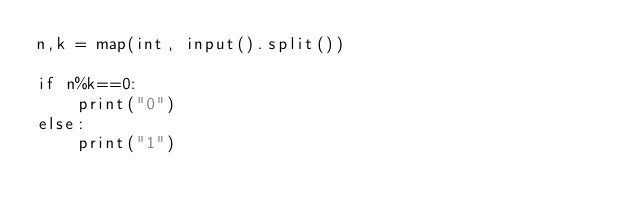<code> <loc_0><loc_0><loc_500><loc_500><_Python_>n,k = map(int, input().split())

if n%k==0:
    print("0")
else:
    print("1")</code> 